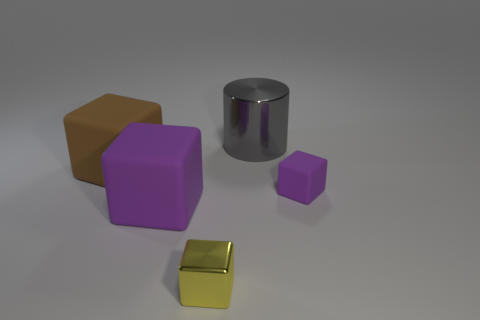There is a thing that is behind the large brown block; does it have the same size as the purple matte object that is left of the small yellow shiny thing?
Offer a very short reply. Yes. Are there any tiny blocks in front of the big brown block?
Your answer should be compact. Yes. There is a small block behind the purple matte cube left of the gray cylinder; what is its color?
Offer a terse response. Purple. Is the number of brown blocks less than the number of matte blocks?
Your response must be concise. Yes. How many tiny shiny things are the same shape as the brown matte object?
Ensure brevity in your answer.  1. There is a matte block that is the same size as the brown thing; what color is it?
Your response must be concise. Purple. Are there an equal number of large purple rubber cubes behind the brown rubber block and metal cylinders in front of the large gray metallic object?
Provide a short and direct response. Yes. Is there a brown rubber block that has the same size as the cylinder?
Give a very brief answer. Yes. What size is the cylinder?
Provide a succinct answer. Large. Are there an equal number of large brown objects that are right of the big metal cylinder and tiny blue things?
Provide a succinct answer. Yes. 